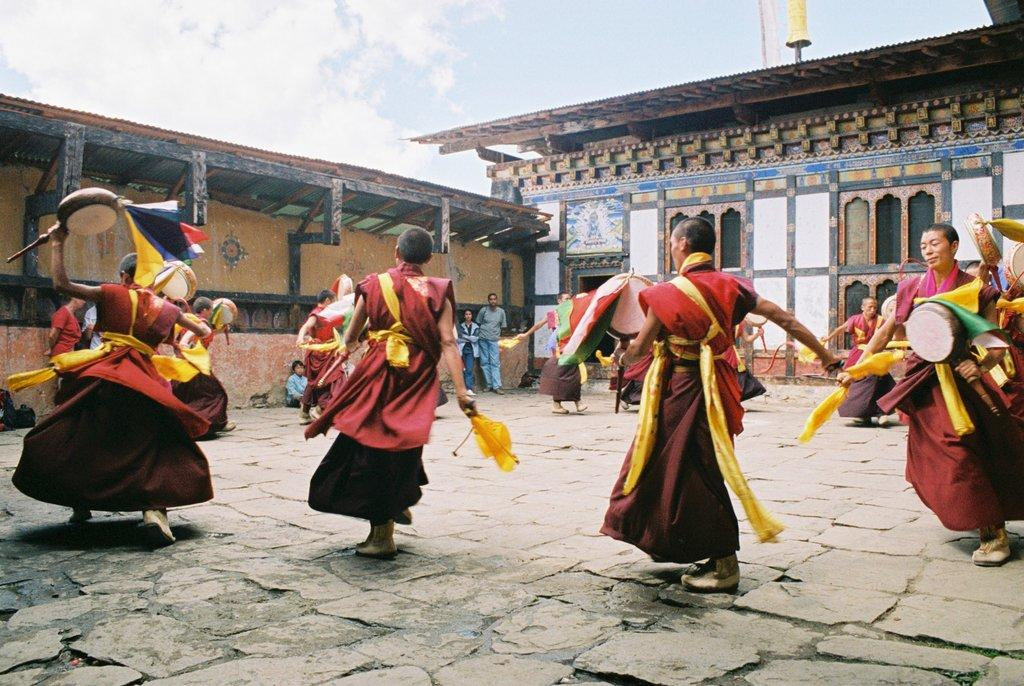How many people can be seen in the image? There are many persons on the ground in the image. What can be seen in the background of the image? There are buildings and the sky visible in the background of the image. What is the condition of the sky in the image? Clouds are present in the sky in the image. What flavor of coat is the person wearing in the image? There is no mention of a coat or any flavor in the image. 